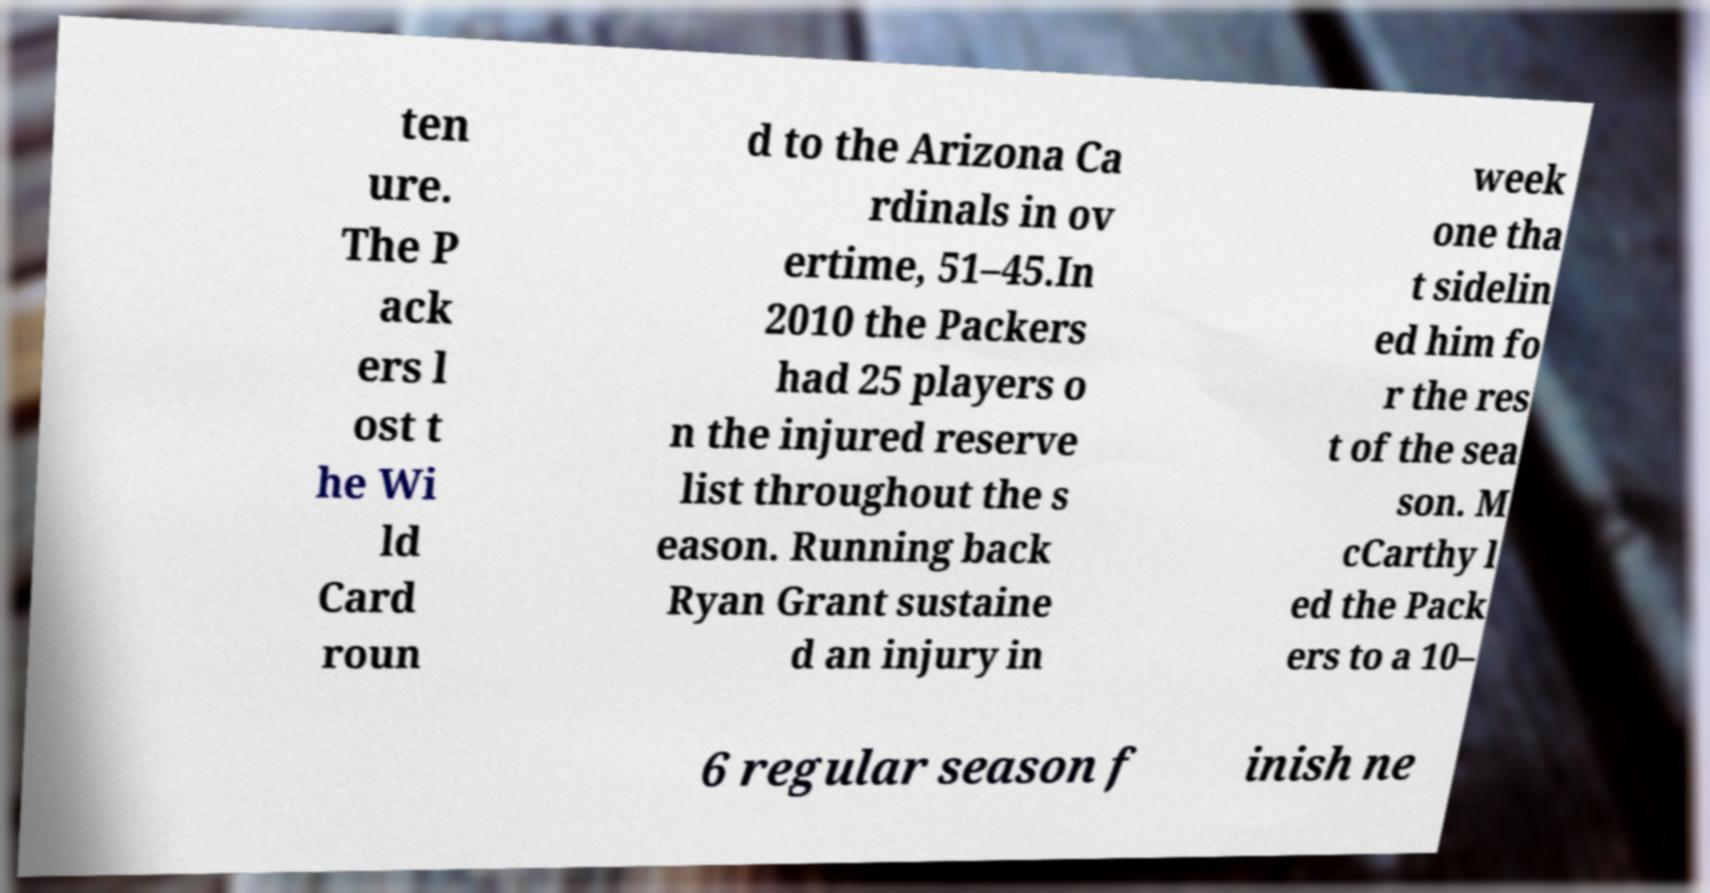Please identify and transcribe the text found in this image. ten ure. The P ack ers l ost t he Wi ld Card roun d to the Arizona Ca rdinals in ov ertime, 51–45.In 2010 the Packers had 25 players o n the injured reserve list throughout the s eason. Running back Ryan Grant sustaine d an injury in week one tha t sidelin ed him fo r the res t of the sea son. M cCarthy l ed the Pack ers to a 10– 6 regular season f inish ne 